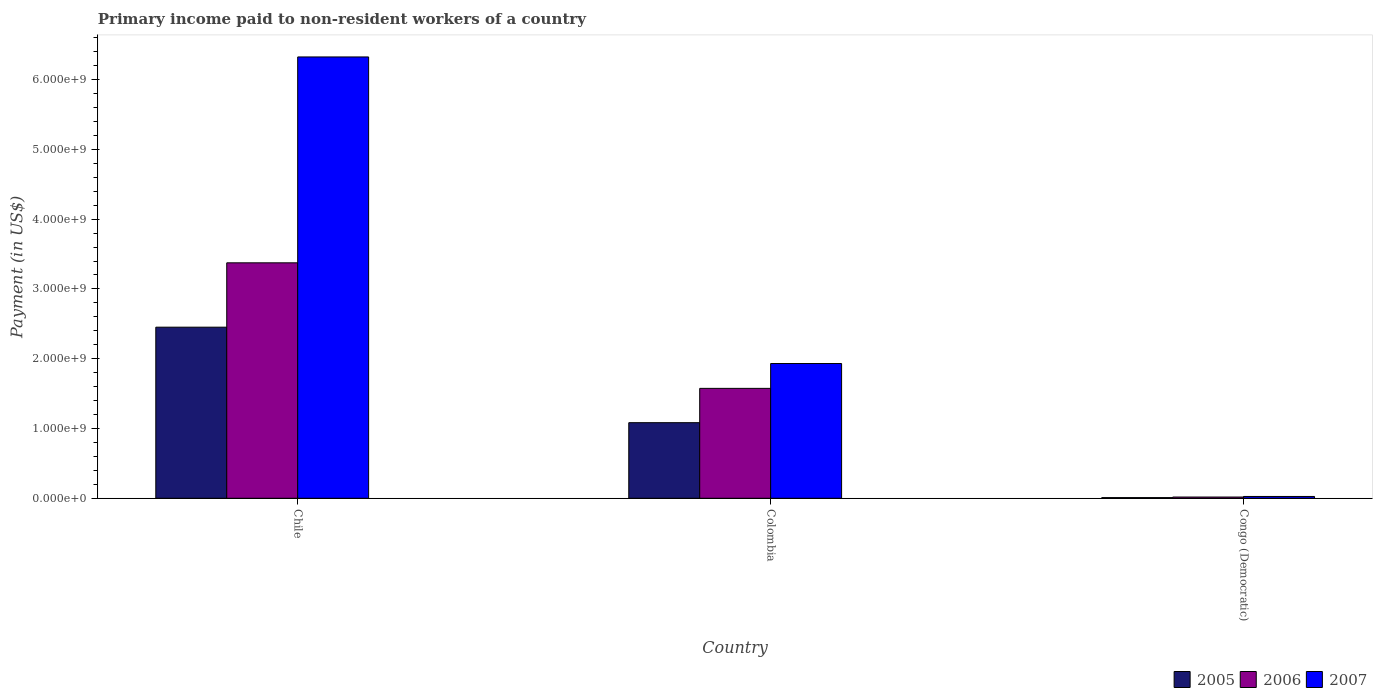Are the number of bars on each tick of the X-axis equal?
Provide a short and direct response. Yes. How many bars are there on the 1st tick from the left?
Offer a very short reply. 3. What is the label of the 3rd group of bars from the left?
Your answer should be very brief. Congo (Democratic). What is the amount paid to workers in 2006 in Chile?
Make the answer very short. 3.37e+09. Across all countries, what is the maximum amount paid to workers in 2005?
Give a very brief answer. 2.45e+09. Across all countries, what is the minimum amount paid to workers in 2005?
Your response must be concise. 9.50e+06. In which country was the amount paid to workers in 2005 maximum?
Your answer should be compact. Chile. In which country was the amount paid to workers in 2005 minimum?
Offer a very short reply. Congo (Democratic). What is the total amount paid to workers in 2006 in the graph?
Make the answer very short. 4.97e+09. What is the difference between the amount paid to workers in 2006 in Chile and that in Congo (Democratic)?
Offer a terse response. 3.36e+09. What is the difference between the amount paid to workers in 2005 in Congo (Democratic) and the amount paid to workers in 2007 in Chile?
Offer a terse response. -6.32e+09. What is the average amount paid to workers in 2005 per country?
Ensure brevity in your answer.  1.18e+09. What is the difference between the amount paid to workers of/in 2005 and amount paid to workers of/in 2006 in Congo (Democratic)?
Your answer should be very brief. -8.20e+06. In how many countries, is the amount paid to workers in 2006 greater than 1400000000 US$?
Make the answer very short. 2. What is the ratio of the amount paid to workers in 2006 in Chile to that in Congo (Democratic)?
Provide a succinct answer. 190.64. What is the difference between the highest and the second highest amount paid to workers in 2007?
Provide a short and direct response. -1.91e+09. What is the difference between the highest and the lowest amount paid to workers in 2007?
Provide a short and direct response. 6.30e+09. In how many countries, is the amount paid to workers in 2007 greater than the average amount paid to workers in 2007 taken over all countries?
Your response must be concise. 1. Is the sum of the amount paid to workers in 2006 in Chile and Congo (Democratic) greater than the maximum amount paid to workers in 2007 across all countries?
Your answer should be very brief. No. What does the 2nd bar from the right in Colombia represents?
Your answer should be very brief. 2006. How many bars are there?
Provide a short and direct response. 9. What is the difference between two consecutive major ticks on the Y-axis?
Keep it short and to the point. 1.00e+09. Are the values on the major ticks of Y-axis written in scientific E-notation?
Offer a terse response. Yes. Does the graph contain any zero values?
Your response must be concise. No. Does the graph contain grids?
Make the answer very short. No. How many legend labels are there?
Your answer should be compact. 3. How are the legend labels stacked?
Ensure brevity in your answer.  Horizontal. What is the title of the graph?
Offer a terse response. Primary income paid to non-resident workers of a country. What is the label or title of the Y-axis?
Make the answer very short. Payment (in US$). What is the Payment (in US$) of 2005 in Chile?
Ensure brevity in your answer.  2.45e+09. What is the Payment (in US$) of 2006 in Chile?
Give a very brief answer. 3.37e+09. What is the Payment (in US$) in 2007 in Chile?
Ensure brevity in your answer.  6.32e+09. What is the Payment (in US$) of 2005 in Colombia?
Give a very brief answer. 1.08e+09. What is the Payment (in US$) in 2006 in Colombia?
Offer a terse response. 1.58e+09. What is the Payment (in US$) of 2007 in Colombia?
Make the answer very short. 1.93e+09. What is the Payment (in US$) of 2005 in Congo (Democratic)?
Offer a very short reply. 9.50e+06. What is the Payment (in US$) in 2006 in Congo (Democratic)?
Your answer should be very brief. 1.77e+07. What is the Payment (in US$) of 2007 in Congo (Democratic)?
Offer a very short reply. 2.60e+07. Across all countries, what is the maximum Payment (in US$) of 2005?
Offer a terse response. 2.45e+09. Across all countries, what is the maximum Payment (in US$) of 2006?
Ensure brevity in your answer.  3.37e+09. Across all countries, what is the maximum Payment (in US$) in 2007?
Offer a very short reply. 6.32e+09. Across all countries, what is the minimum Payment (in US$) in 2005?
Offer a terse response. 9.50e+06. Across all countries, what is the minimum Payment (in US$) of 2006?
Your answer should be very brief. 1.77e+07. Across all countries, what is the minimum Payment (in US$) in 2007?
Provide a succinct answer. 2.60e+07. What is the total Payment (in US$) in 2005 in the graph?
Give a very brief answer. 3.55e+09. What is the total Payment (in US$) in 2006 in the graph?
Keep it short and to the point. 4.97e+09. What is the total Payment (in US$) of 2007 in the graph?
Offer a very short reply. 8.28e+09. What is the difference between the Payment (in US$) of 2005 in Chile and that in Colombia?
Provide a succinct answer. 1.37e+09. What is the difference between the Payment (in US$) in 2006 in Chile and that in Colombia?
Ensure brevity in your answer.  1.80e+09. What is the difference between the Payment (in US$) in 2007 in Chile and that in Colombia?
Make the answer very short. 4.39e+09. What is the difference between the Payment (in US$) in 2005 in Chile and that in Congo (Democratic)?
Ensure brevity in your answer.  2.44e+09. What is the difference between the Payment (in US$) of 2006 in Chile and that in Congo (Democratic)?
Offer a very short reply. 3.36e+09. What is the difference between the Payment (in US$) in 2007 in Chile and that in Congo (Democratic)?
Give a very brief answer. 6.30e+09. What is the difference between the Payment (in US$) in 2005 in Colombia and that in Congo (Democratic)?
Your answer should be very brief. 1.07e+09. What is the difference between the Payment (in US$) of 2006 in Colombia and that in Congo (Democratic)?
Keep it short and to the point. 1.56e+09. What is the difference between the Payment (in US$) of 2007 in Colombia and that in Congo (Democratic)?
Your answer should be very brief. 1.91e+09. What is the difference between the Payment (in US$) of 2005 in Chile and the Payment (in US$) of 2006 in Colombia?
Your response must be concise. 8.77e+08. What is the difference between the Payment (in US$) of 2005 in Chile and the Payment (in US$) of 2007 in Colombia?
Keep it short and to the point. 5.21e+08. What is the difference between the Payment (in US$) of 2006 in Chile and the Payment (in US$) of 2007 in Colombia?
Ensure brevity in your answer.  1.44e+09. What is the difference between the Payment (in US$) of 2005 in Chile and the Payment (in US$) of 2006 in Congo (Democratic)?
Your response must be concise. 2.43e+09. What is the difference between the Payment (in US$) in 2005 in Chile and the Payment (in US$) in 2007 in Congo (Democratic)?
Your answer should be very brief. 2.43e+09. What is the difference between the Payment (in US$) in 2006 in Chile and the Payment (in US$) in 2007 in Congo (Democratic)?
Provide a succinct answer. 3.35e+09. What is the difference between the Payment (in US$) of 2005 in Colombia and the Payment (in US$) of 2006 in Congo (Democratic)?
Ensure brevity in your answer.  1.07e+09. What is the difference between the Payment (in US$) in 2005 in Colombia and the Payment (in US$) in 2007 in Congo (Democratic)?
Keep it short and to the point. 1.06e+09. What is the difference between the Payment (in US$) in 2006 in Colombia and the Payment (in US$) in 2007 in Congo (Democratic)?
Offer a terse response. 1.55e+09. What is the average Payment (in US$) in 2005 per country?
Offer a very short reply. 1.18e+09. What is the average Payment (in US$) in 2006 per country?
Keep it short and to the point. 1.66e+09. What is the average Payment (in US$) of 2007 per country?
Offer a terse response. 2.76e+09. What is the difference between the Payment (in US$) in 2005 and Payment (in US$) in 2006 in Chile?
Ensure brevity in your answer.  -9.22e+08. What is the difference between the Payment (in US$) of 2005 and Payment (in US$) of 2007 in Chile?
Provide a short and direct response. -3.87e+09. What is the difference between the Payment (in US$) in 2006 and Payment (in US$) in 2007 in Chile?
Your answer should be very brief. -2.95e+09. What is the difference between the Payment (in US$) in 2005 and Payment (in US$) in 2006 in Colombia?
Provide a short and direct response. -4.92e+08. What is the difference between the Payment (in US$) of 2005 and Payment (in US$) of 2007 in Colombia?
Give a very brief answer. -8.48e+08. What is the difference between the Payment (in US$) of 2006 and Payment (in US$) of 2007 in Colombia?
Your answer should be very brief. -3.56e+08. What is the difference between the Payment (in US$) of 2005 and Payment (in US$) of 2006 in Congo (Democratic)?
Your response must be concise. -8.20e+06. What is the difference between the Payment (in US$) of 2005 and Payment (in US$) of 2007 in Congo (Democratic)?
Make the answer very short. -1.65e+07. What is the difference between the Payment (in US$) of 2006 and Payment (in US$) of 2007 in Congo (Democratic)?
Ensure brevity in your answer.  -8.30e+06. What is the ratio of the Payment (in US$) of 2005 in Chile to that in Colombia?
Offer a very short reply. 2.26. What is the ratio of the Payment (in US$) in 2006 in Chile to that in Colombia?
Give a very brief answer. 2.14. What is the ratio of the Payment (in US$) in 2007 in Chile to that in Colombia?
Make the answer very short. 3.27. What is the ratio of the Payment (in US$) in 2005 in Chile to that in Congo (Democratic)?
Your answer should be very brief. 258.12. What is the ratio of the Payment (in US$) of 2006 in Chile to that in Congo (Democratic)?
Your answer should be very brief. 190.64. What is the ratio of the Payment (in US$) in 2007 in Chile to that in Congo (Democratic)?
Make the answer very short. 243.27. What is the ratio of the Payment (in US$) in 2005 in Colombia to that in Congo (Democratic)?
Offer a very short reply. 114.05. What is the ratio of the Payment (in US$) in 2006 in Colombia to that in Congo (Democratic)?
Provide a succinct answer. 88.99. What is the ratio of the Payment (in US$) of 2007 in Colombia to that in Congo (Democratic)?
Give a very brief answer. 74.28. What is the difference between the highest and the second highest Payment (in US$) of 2005?
Offer a very short reply. 1.37e+09. What is the difference between the highest and the second highest Payment (in US$) of 2006?
Provide a succinct answer. 1.80e+09. What is the difference between the highest and the second highest Payment (in US$) in 2007?
Give a very brief answer. 4.39e+09. What is the difference between the highest and the lowest Payment (in US$) in 2005?
Make the answer very short. 2.44e+09. What is the difference between the highest and the lowest Payment (in US$) of 2006?
Provide a short and direct response. 3.36e+09. What is the difference between the highest and the lowest Payment (in US$) of 2007?
Your answer should be compact. 6.30e+09. 